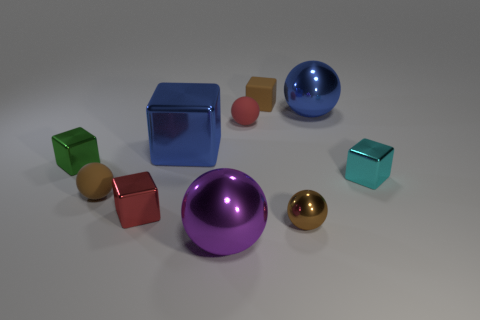What is the size of the blue metal thing on the left side of the big purple ball?
Ensure brevity in your answer.  Large. There is a blue thing that is left of the large shiny thing that is in front of the red thing that is to the left of the red matte object; what shape is it?
Your answer should be very brief. Cube. What is the shape of the metallic thing that is in front of the cyan cube and left of the purple ball?
Make the answer very short. Cube. Are there any cyan metal things of the same size as the brown metal sphere?
Provide a succinct answer. Yes. There is a large blue metallic thing that is in front of the red sphere; is it the same shape as the cyan object?
Provide a short and direct response. Yes. Do the cyan metallic object and the green metal object have the same shape?
Provide a short and direct response. Yes. Are there any blue things of the same shape as the big purple shiny object?
Keep it short and to the point. Yes. What is the shape of the brown matte object that is behind the tiny metallic block on the right side of the small rubber cube?
Give a very brief answer. Cube. There is a tiny cube that is to the left of the small red cube; what color is it?
Offer a very short reply. Green. There is a green object that is made of the same material as the big cube; what is its size?
Offer a terse response. Small. 